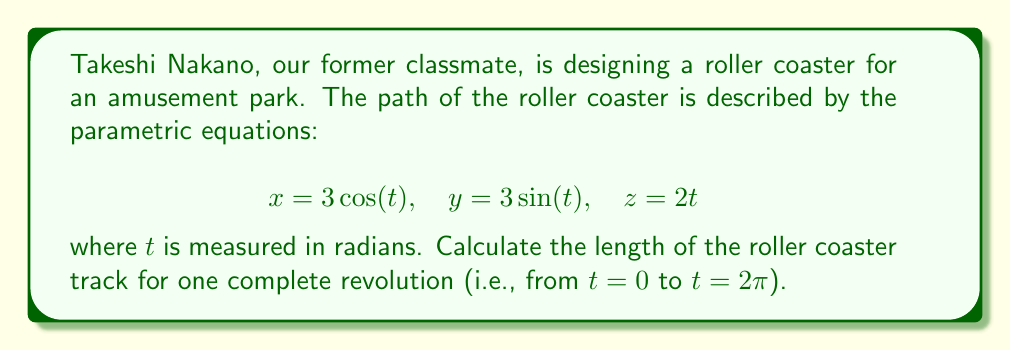Could you help me with this problem? To find the arc length of a parametric curve in three-dimensional space, we use the formula:

$$L = \int_{a}^{b} \sqrt{\left(\frac{dx}{dt}\right)^2 + \left(\frac{dy}{dt}\right)^2 + \left(\frac{dz}{dt}\right)^2} dt$$

Step 1: Find the derivatives of x, y, and z with respect to t.
$$\frac{dx}{dt} = -3\sin(t)$$
$$\frac{dy}{dt} = 3\cos(t)$$
$$\frac{dz}{dt} = 2$$

Step 2: Square each derivative and add them together.
$$\left(\frac{dx}{dt}\right)^2 + \left(\frac{dy}{dt}\right)^2 + \left(\frac{dz}{dt}\right)^2 = (-3\sin(t))^2 + (3\cos(t))^2 + 2^2$$
$$= 9\sin^2(t) + 9\cos^2(t) + 4$$
$$= 9(\sin^2(t) + \cos^2(t)) + 4$$
$$= 9 + 4 = 13$$

Step 3: Take the square root of the result from Step 2.
$$\sqrt{\left(\frac{dx}{dt}\right)^2 + \left(\frac{dy}{dt}\right)^2 + \left(\frac{dz}{dt}\right)^2} = \sqrt{13}$$

Step 4: Integrate from 0 to 2π.
$$L = \int_{0}^{2\pi} \sqrt{13} dt = \sqrt{13} \int_{0}^{2\pi} dt = \sqrt{13} [t]_{0}^{2\pi} = 2\pi\sqrt{13}$$

Therefore, the length of the roller coaster track for one complete revolution is $2\pi\sqrt{13}$.
Answer: $2\pi\sqrt{13}$ 